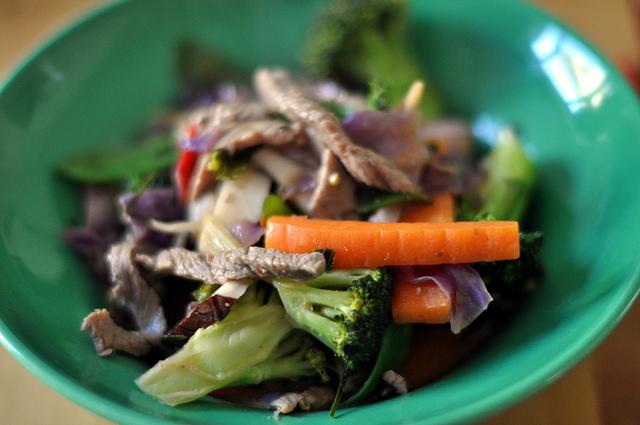Is the entire photo in focus?
Answer briefly. No. What color is the container?
Keep it brief. Green. What color is the bowl?
Keep it brief. Green. Is this a nutritionally balanced meal choice?
Write a very short answer. Yes. Is this a vegetarian meal?
Be succinct. No. 